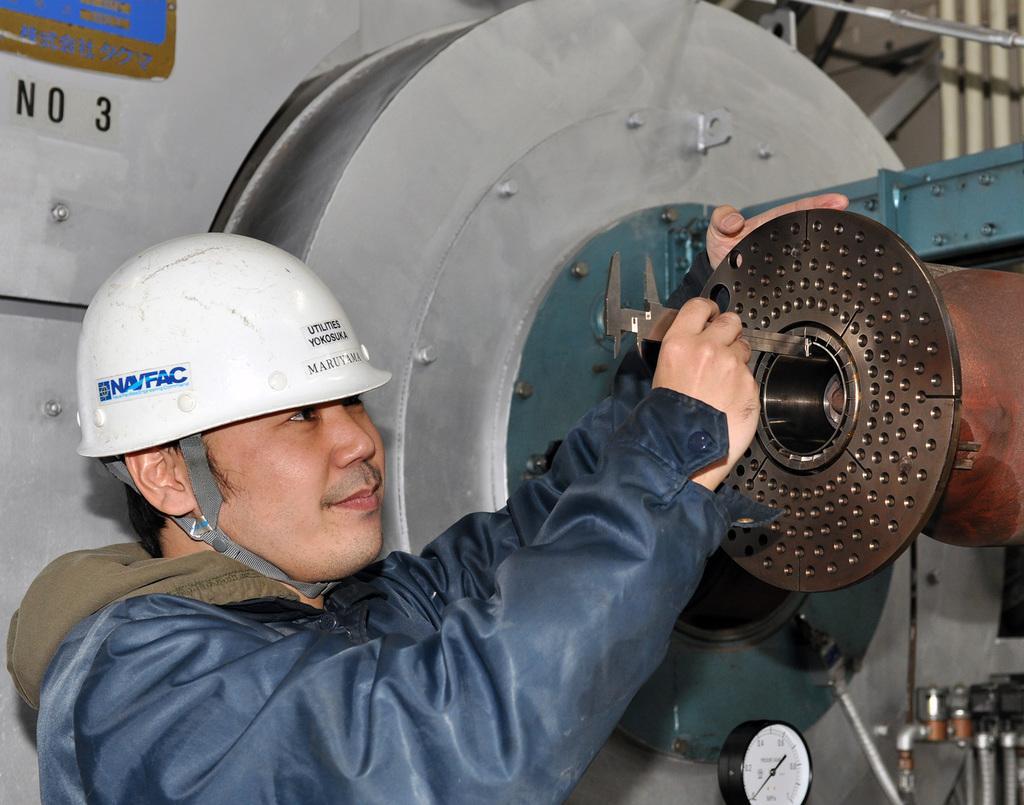How would you summarize this image in a sentence or two? In this image a man wearing helmet and jacket is holding a slide caliper. In the right there is machine. 